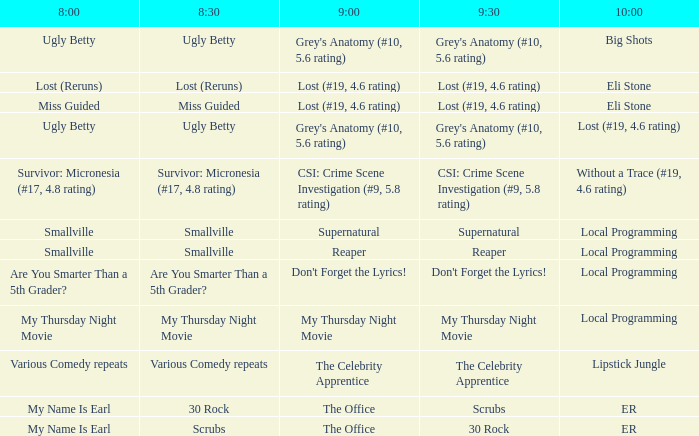Could you parse the entire table as a dict? {'header': ['8:00', '8:30', '9:00', '9:30', '10:00'], 'rows': [['Ugly Betty', 'Ugly Betty', "Grey's Anatomy (#10, 5.6 rating)", "Grey's Anatomy (#10, 5.6 rating)", 'Big Shots'], ['Lost (Reruns)', 'Lost (Reruns)', 'Lost (#19, 4.6 rating)', 'Lost (#19, 4.6 rating)', 'Eli Stone'], ['Miss Guided', 'Miss Guided', 'Lost (#19, 4.6 rating)', 'Lost (#19, 4.6 rating)', 'Eli Stone'], ['Ugly Betty', 'Ugly Betty', "Grey's Anatomy (#10, 5.6 rating)", "Grey's Anatomy (#10, 5.6 rating)", 'Lost (#19, 4.6 rating)'], ['Survivor: Micronesia (#17, 4.8 rating)', 'Survivor: Micronesia (#17, 4.8 rating)', 'CSI: Crime Scene Investigation (#9, 5.8 rating)', 'CSI: Crime Scene Investigation (#9, 5.8 rating)', 'Without a Trace (#19, 4.6 rating)'], ['Smallville', 'Smallville', 'Supernatural', 'Supernatural', 'Local Programming'], ['Smallville', 'Smallville', 'Reaper', 'Reaper', 'Local Programming'], ['Are You Smarter Than a 5th Grader?', 'Are You Smarter Than a 5th Grader?', "Don't Forget the Lyrics!", "Don't Forget the Lyrics!", 'Local Programming'], ['My Thursday Night Movie', 'My Thursday Night Movie', 'My Thursday Night Movie', 'My Thursday Night Movie', 'Local Programming'], ['Various Comedy repeats', 'Various Comedy repeats', 'The Celebrity Apprentice', 'The Celebrity Apprentice', 'Lipstick Jungle'], ['My Name Is Earl', '30 Rock', 'The Office', 'Scrubs', 'ER'], ['My Name Is Earl', 'Scrubs', 'The Office', '30 Rock', 'ER']]} What happens at 10:00 if something is lost at 9:00 (#19, 4.6 rating) and again at 8:30 (reruns)? Eli Stone. 